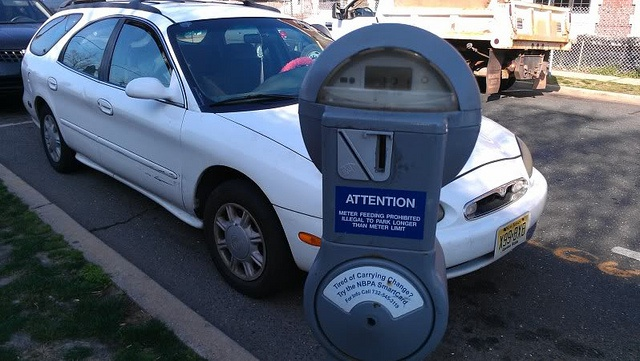Describe the objects in this image and their specific colors. I can see car in darkblue, black, lightblue, gray, and navy tones, parking meter in darkblue, navy, black, and gray tones, truck in darkblue, ivory, black, tan, and darkgray tones, car in darkblue, navy, black, and gray tones, and people in darkblue, navy, and gray tones in this image. 